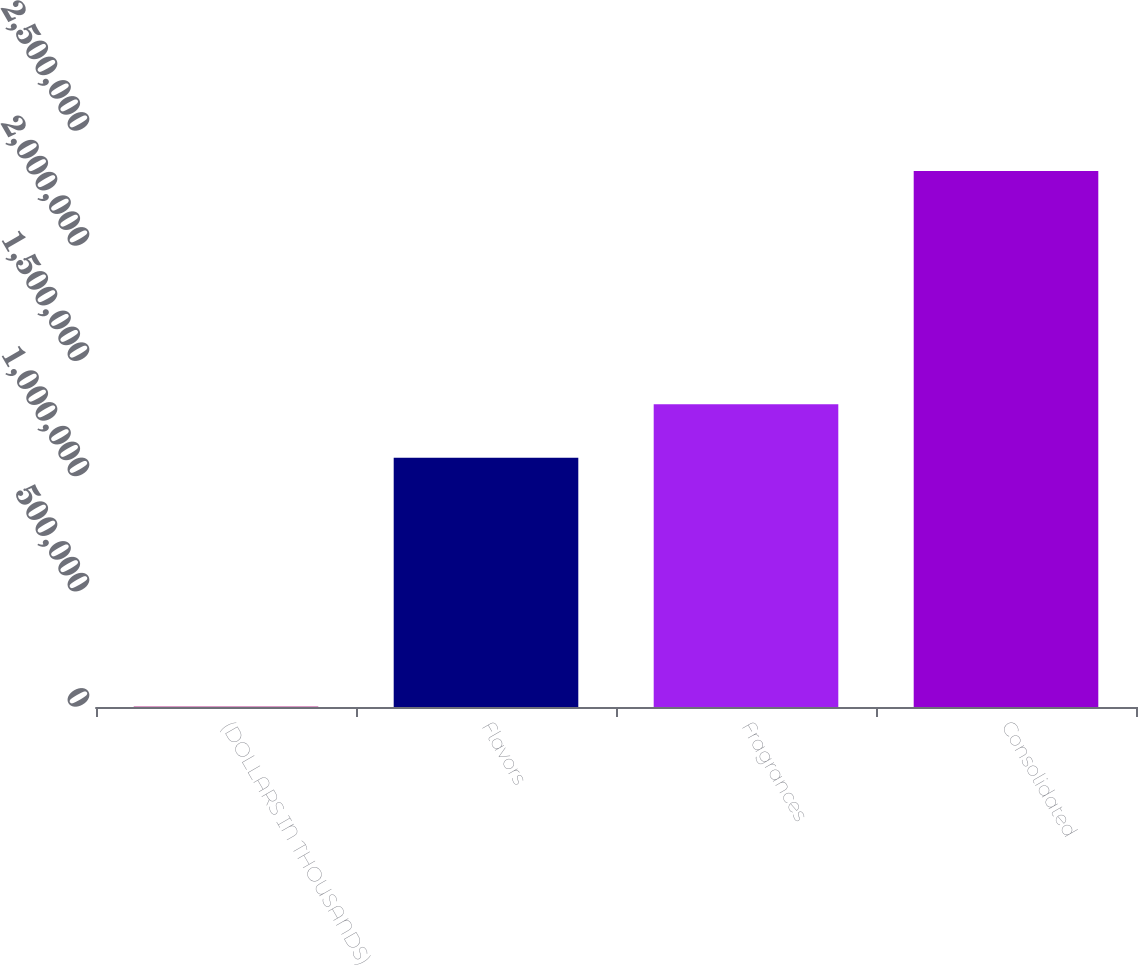Convert chart. <chart><loc_0><loc_0><loc_500><loc_500><bar_chart><fcel>(DOLLARS IN THOUSANDS)<fcel>Flavors<fcel>Fragrances<fcel>Consolidated<nl><fcel>2009<fcel>1.08149e+06<fcel>1.3139e+06<fcel>2.32616e+06<nl></chart> 